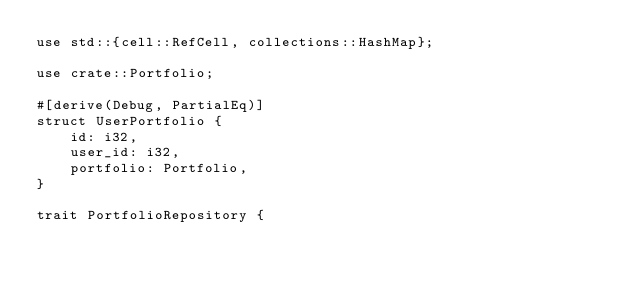<code> <loc_0><loc_0><loc_500><loc_500><_Rust_>use std::{cell::RefCell, collections::HashMap};

use crate::Portfolio;

#[derive(Debug, PartialEq)]
struct UserPortfolio {
    id: i32,
    user_id: i32,
    portfolio: Portfolio,
}

trait PortfolioRepository {</code> 